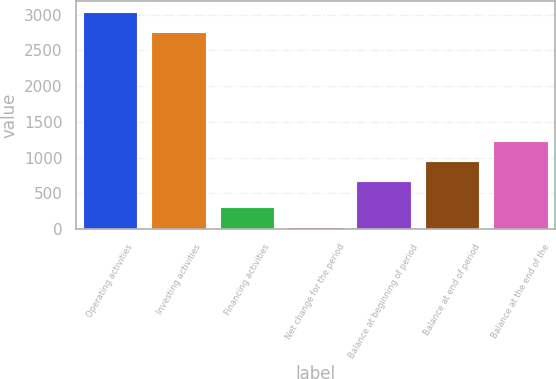Convert chart to OTSL. <chart><loc_0><loc_0><loc_500><loc_500><bar_chart><fcel>Operating activities<fcel>Investing activities<fcel>Financing activities<fcel>Net change for the period<fcel>Balance at beginning of period<fcel>Balance at end of period<fcel>Balance at the end of the<nl><fcel>3039.6<fcel>2759<fcel>305.6<fcel>25<fcel>674<fcel>954.6<fcel>1235.2<nl></chart> 